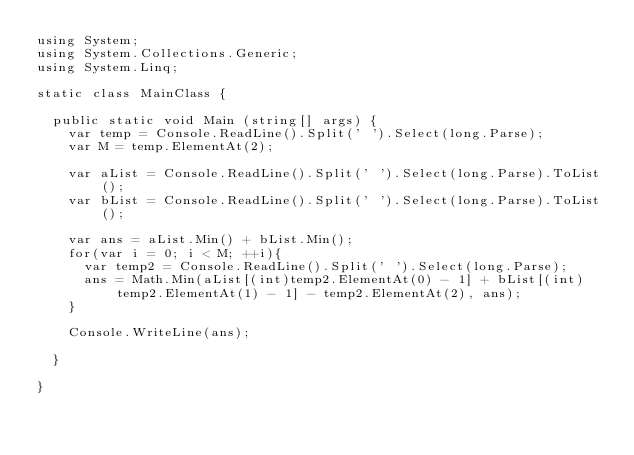Convert code to text. <code><loc_0><loc_0><loc_500><loc_500><_C#_>using System;
using System.Collections.Generic;
using System.Linq;
 
static class MainClass {
 
  public static void Main (string[] args) {
    var temp = Console.ReadLine().Split(' ').Select(long.Parse);
    var M = temp.ElementAt(2);

    var aList = Console.ReadLine().Split(' ').Select(long.Parse).ToList();
    var bList = Console.ReadLine().Split(' ').Select(long.Parse).ToList();

    var ans = aList.Min() + bList.Min();
    for(var i = 0; i < M; ++i){
      var temp2 = Console.ReadLine().Split(' ').Select(long.Parse);
      ans = Math.Min(aList[(int)temp2.ElementAt(0) - 1] + bList[(int)temp2.ElementAt(1) - 1] - temp2.ElementAt(2), ans);
    }
   
    Console.WriteLine(ans);
 
  }
  
}</code> 